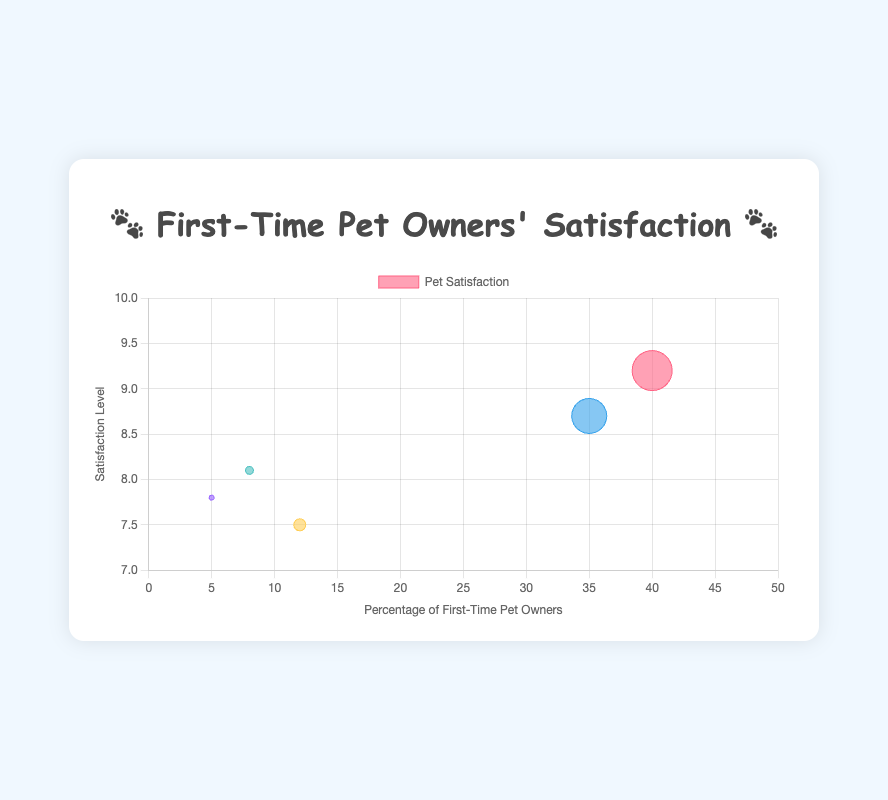What type of pet is owned by the highest percentage of first-time pet owners? The figure shows a bubble chart with various pets represented by different emojis. By examining the x-axis, "🐶 Dog" has the largest bubble size and the highest position on the x-axis at 40%. Hence, "🐶 Dog" is the pet owned by the highest percentage of first-time pet owners.
Answer: 🐶 Dog Which pet has the highest satisfaction level? The y-axis represents the satisfaction level. Observing the y-values of the bubbles, "🐶 Dog" has the highest y-value of 9.2. Therefore, "🐶 Dog" has the highest satisfaction level.
Answer: 🐶 Dog How does the satisfaction level of owning a rabbit compare to owning a cat? The y-axis shows satisfaction levels. "🐱 Cat" has a satisfaction level of 8.7, while "🐰 Rabbit" has a satisfaction level of 8.1. "🐱 Cat" has a higher satisfaction level than "🐰 Rabbit."
Answer: 🐱 Cat has higher satisfaction What is the combined percentage of first-time pet owners who own either a fish or a parakeet? The percentage of first-time pet owners is shown on the x-axis. Adding the percentages of "🐠 Fish" (12%) and "🐦 Parakeet" (5%) gives 12% + 5% = 17%.
Answer: 17% What is the difference in satisfaction level between owning a dog and owning a parakeet? The satisfaction levels are shown on the y-axis. "🐶 Dog" has a satisfaction level of 9.2, and "🐦 Parakeet" has a satisfaction level of 7.8. The difference is 9.2 - 7.8 = 1.4.
Answer: 1.4 Which pet has the smallest representation among first-time pet owners? Observing the x-axis for the smallest value, "🐦 Parakeet" is represented at 5%, which is the smallest percentage among all pets.
Answer: 🐦 Parakeet What is the average satisfaction level for the pets listed? The satisfaction levels are 9.2, 8.7, 7.5, 8.1, and 7.8. Summing them 9.2 + 8.7 + 7.5 + 8.1 + 7.8 = 41.3, then dividing by 5 gives 41.3 / 5 = 8.26. The average satisfaction level is 8.26.
Answer: 8.26 Which pet has a satisfaction level closest to 8? Examining the y-axis values close to 8, "🐦 Parakeet" has a satisfaction level of 7.8 which is closest to 8.
Answer: 🐦 Parakeet How many pets have a satisfaction level greater than 8? The y-axis represents satisfaction levels. Pets with satisfaction levels > 8 are "🐶 Dog" (9.2), "🐱 Cat" (8.7), and "🐰 Rabbit" (8.1). Thus, there are 3 pets with satisfaction levels greater than 8.
Answer: 3 